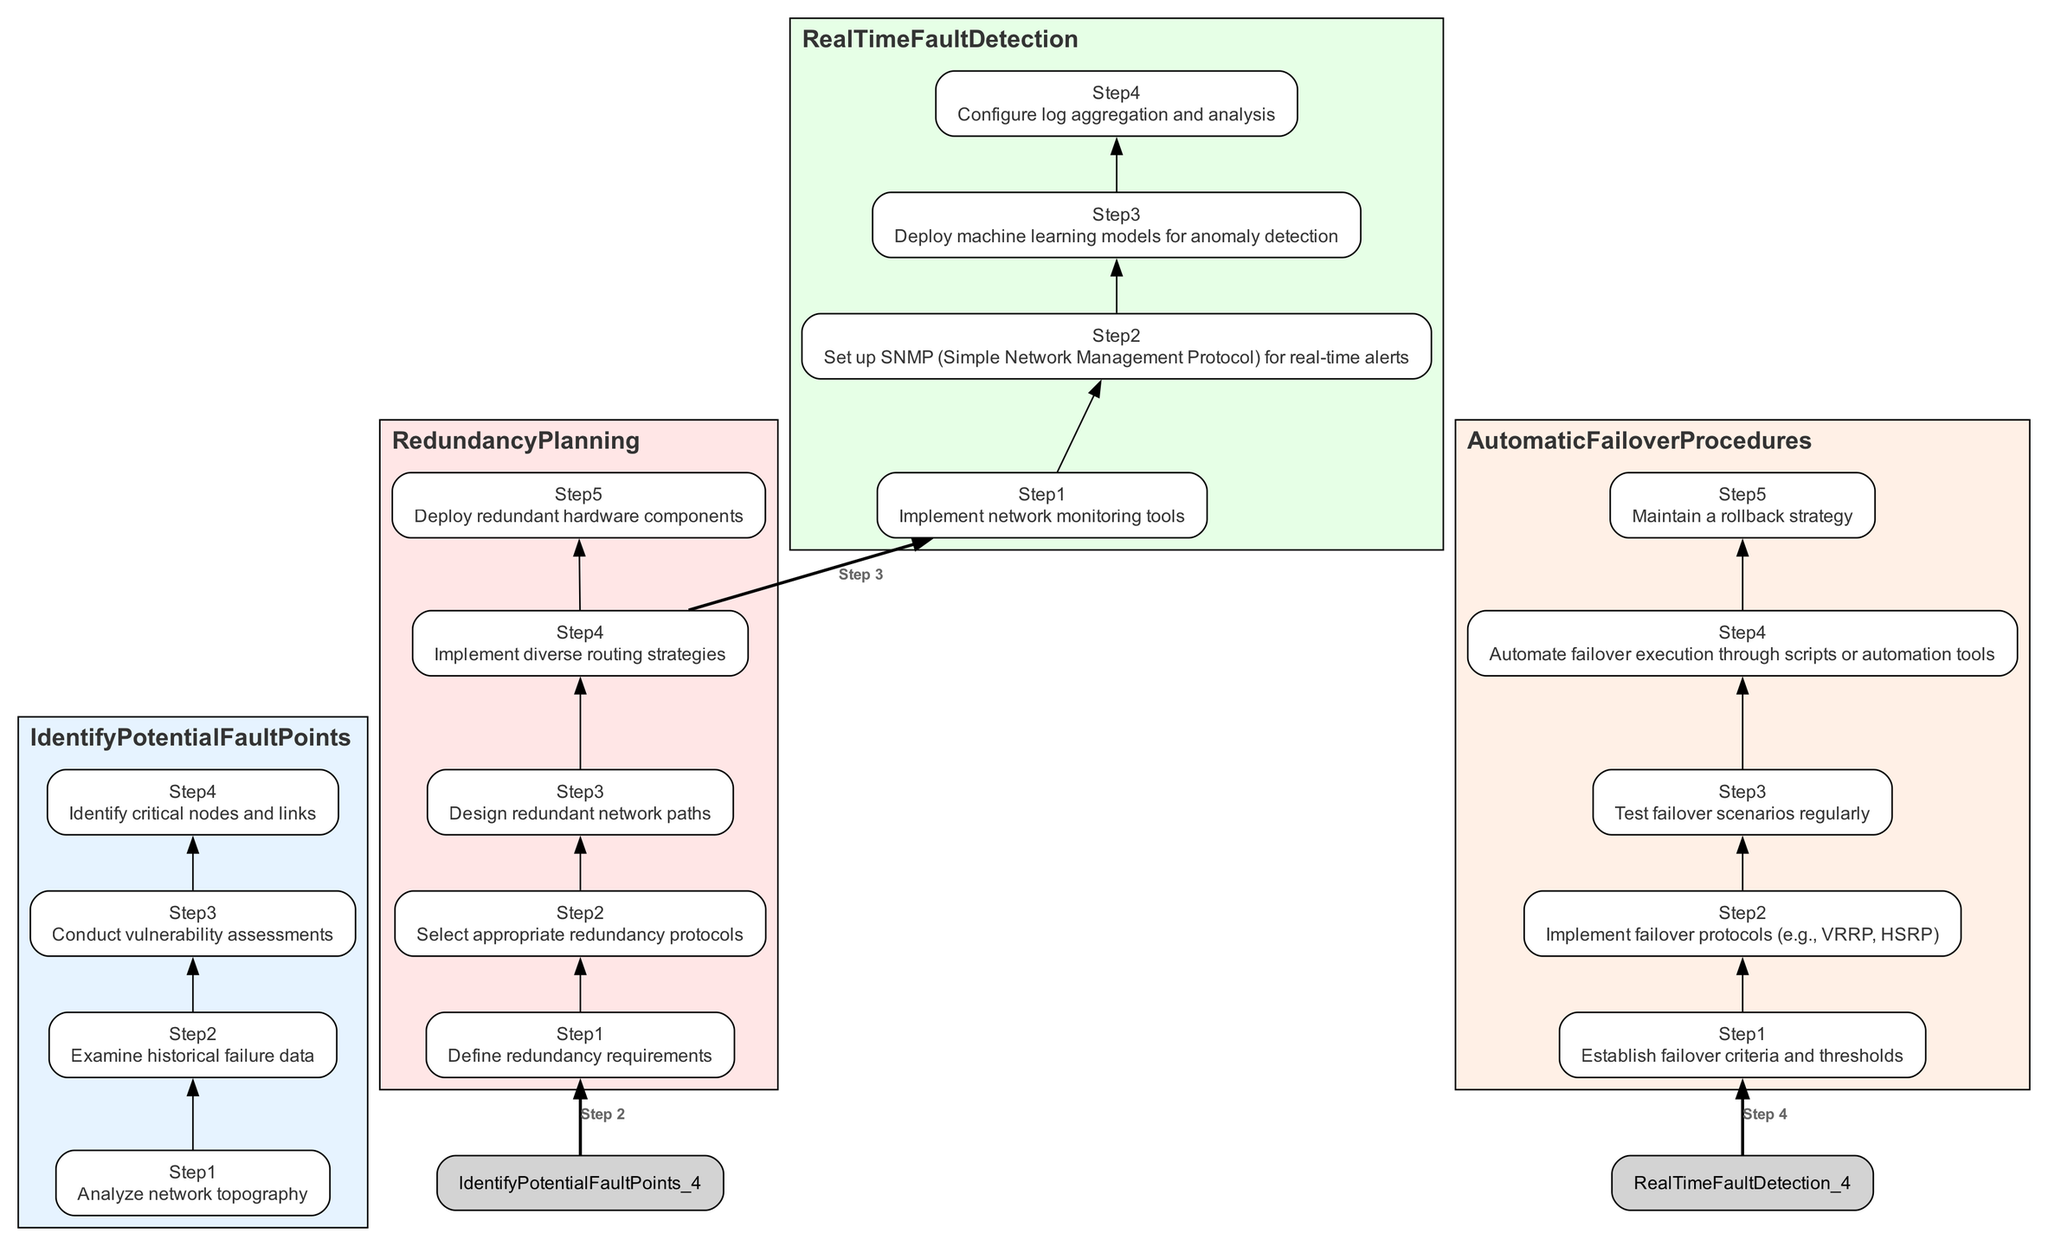What is the first step in identifying potential fault points? The first step is to analyze network topography. This is indicated as the initial step listed under the "Identify Potential Fault Points" section of the diagram.
Answer: Analyze network topography How many steps are involved in redundancy planning? There are five steps involved in redundancy planning, as seen in the "Redundancy Planning" section of the diagram where five individual steps are listed.
Answer: Five What is the last step of the real-time fault detection process? The last step in the "Real-Time Fault Detection" section is to configure log aggregation and analysis, as it is listed as the fourth step in that category.
Answer: Configure log aggregation and analysis Which step follows defining redundancy requirements? The step that follows defining redundancy requirements is selecting appropriate redundancy protocols. This follows logically from the flow of steps listed under "Redundancy Planning."
Answer: Select appropriate redundancy protocols What is the relationship between the last step of automatic failover procedures and the overall flow? The last step of automatic failover procedures maintains a rollback strategy, which summarizes the procedures and ensures preparedness for unexpected scenarios. It completes the flow by providing a safety net, reinforcing system reliability throughout the entire process.
Answer: Maintains a rollback strategy How many main sections are present in the diagram? The diagram contains four main sections, which are "Identify Potential Fault Points," "Redundancy Planning," "Real-Time Fault Detection," and "Automatic Failover Procedures." Each section represents a critical stage in the fault-tolerant design process.
Answer: Four What step is directly before implementing failover protocols? The step directly before implementing failover protocols is establishing failover criteria and thresholds. This order is important since determining the criteria is essential before moving to the next protocol implementation.
Answer: Establish failover criteria and thresholds Which step utilizes machine learning models? The step that utilizes machine learning models is to deploy machine learning models for anomaly detection, which is part of the "Real-Time Fault Detection" section, focusing on detecting issues proactively.
Answer: Deploy machine learning models for anomaly detection What is indicated as a critical aspect of testing in automatic failover procedures? Testing failover scenarios regularly is highlighted as a critical aspect in the automatic failover procedures section, ensuring that the failover mechanisms function as intended.
Answer: Test failover scenarios regularly 